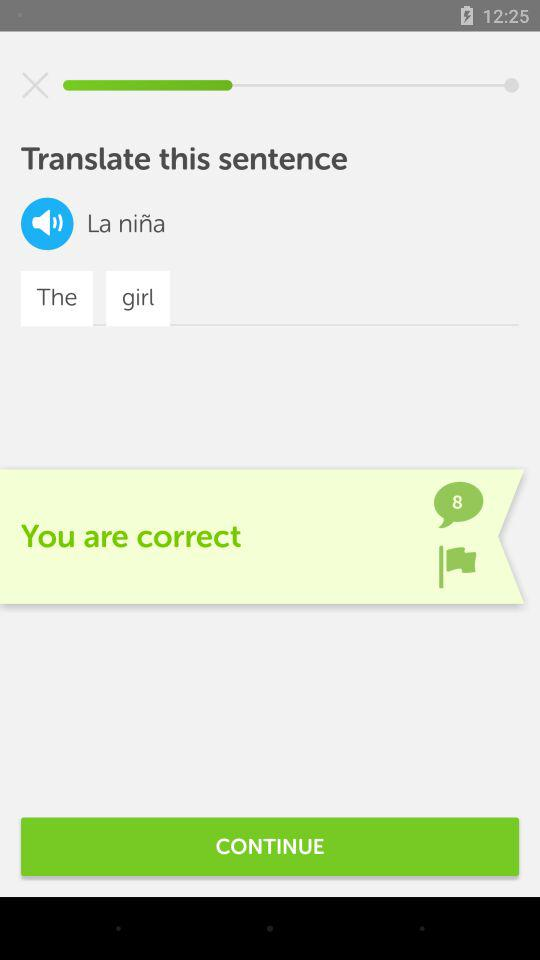What is the number of comments? The number of comments is 8. 